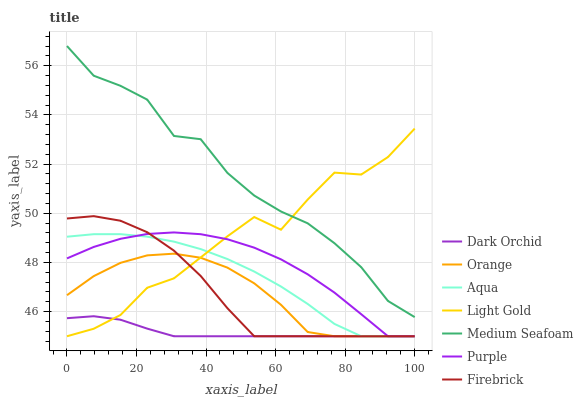Does Dark Orchid have the minimum area under the curve?
Answer yes or no. Yes. Does Medium Seafoam have the maximum area under the curve?
Answer yes or no. Yes. Does Firebrick have the minimum area under the curve?
Answer yes or no. No. Does Firebrick have the maximum area under the curve?
Answer yes or no. No. Is Dark Orchid the smoothest?
Answer yes or no. Yes. Is Light Gold the roughest?
Answer yes or no. Yes. Is Firebrick the smoothest?
Answer yes or no. No. Is Firebrick the roughest?
Answer yes or no. No. Does Medium Seafoam have the lowest value?
Answer yes or no. No. Does Firebrick have the highest value?
Answer yes or no. No. Is Aqua less than Medium Seafoam?
Answer yes or no. Yes. Is Medium Seafoam greater than Orange?
Answer yes or no. Yes. Does Aqua intersect Medium Seafoam?
Answer yes or no. No. 